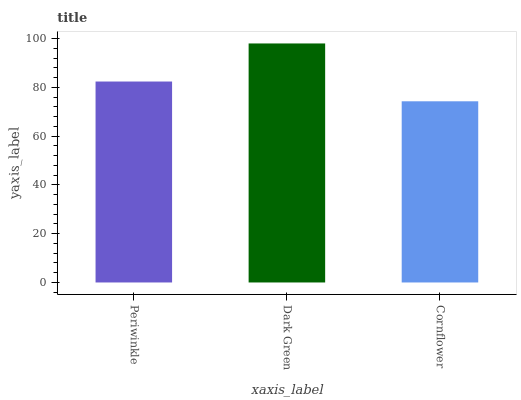Is Cornflower the minimum?
Answer yes or no. Yes. Is Dark Green the maximum?
Answer yes or no. Yes. Is Dark Green the minimum?
Answer yes or no. No. Is Cornflower the maximum?
Answer yes or no. No. Is Dark Green greater than Cornflower?
Answer yes or no. Yes. Is Cornflower less than Dark Green?
Answer yes or no. Yes. Is Cornflower greater than Dark Green?
Answer yes or no. No. Is Dark Green less than Cornflower?
Answer yes or no. No. Is Periwinkle the high median?
Answer yes or no. Yes. Is Periwinkle the low median?
Answer yes or no. Yes. Is Cornflower the high median?
Answer yes or no. No. Is Dark Green the low median?
Answer yes or no. No. 